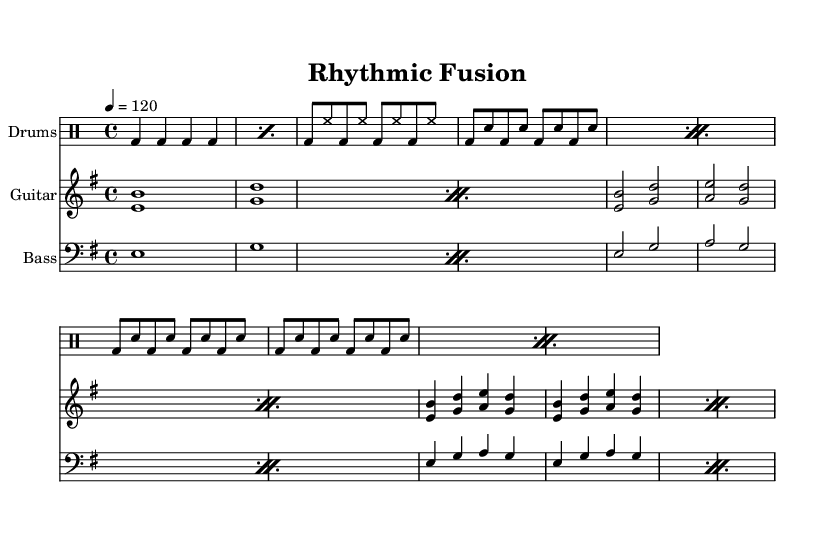What is the key signature of this music? The key signature of the music is E minor, which consists of one sharp (F#).
Answer: E minor What is the time signature of this music? The time signature is 4/4, which means there are four beats in each measure and the quarter note gets one beat.
Answer: 4/4 What is the tempo marking for this piece? The tempo marking indicates a speed of 120 beats per minute, which expresses a moderate tempo.
Answer: 120 How many measures are in the drum introduction? The drum introduction consists of 4 measures, as indicated by the counting of quarter notes and repeat markings.
Answer: 4 What rhythmic pattern is primarily used in the verse section? The verse section primarily features a combination of bass drum and hi-hat interplay, with bass drum hits on the eighth notes.
Answer: Bass drum and hi-hat In the chorus, how is the rhythm structured in relation to the snare hits? In the chorus, the rhythm is structured with consistent bass drum and snare hits alternating on the eighth notes, creating a driving groove.
Answer: Alternating eighth notes What instrument plays the root note during the introduction? The bass guitar plays the root note during the introduction, providing foundational support for the harmonic structure.
Answer: Bass guitar 